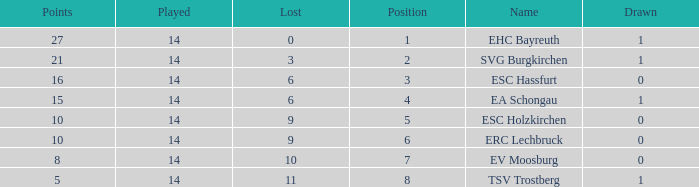What's the lost when there were more than 16 points and had a drawn less than 1? None. 